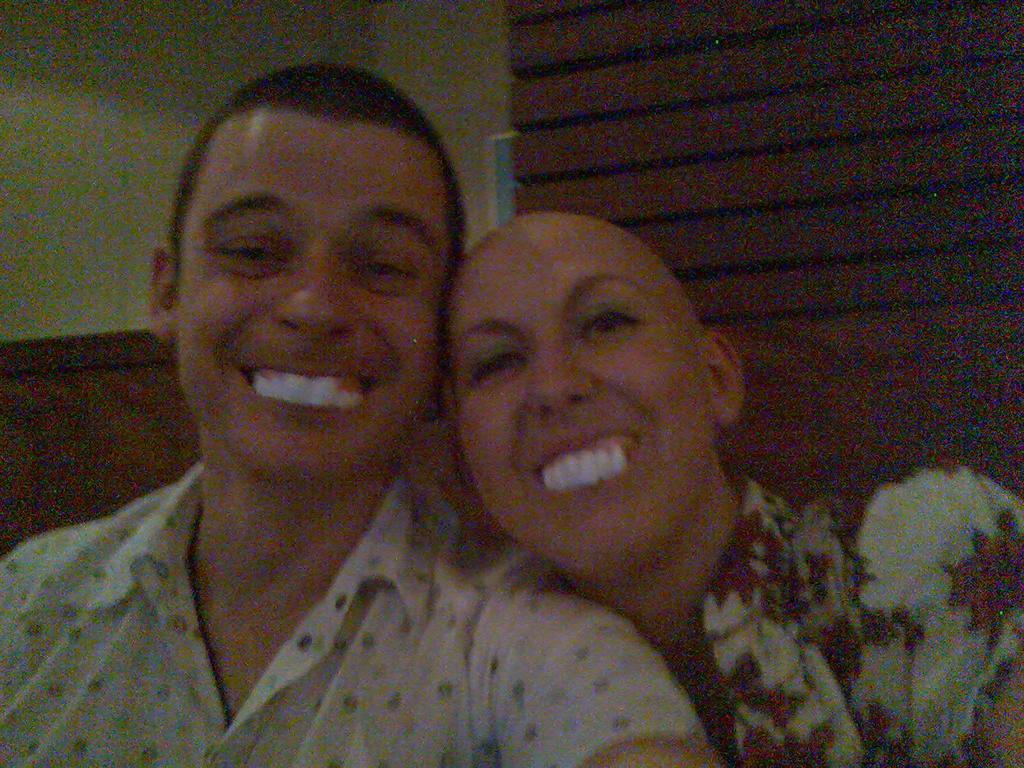Describe this image in one or two sentences. In this image there is a man and a lady. They both are smiling. In the background there is a wall. The lady is wearing a floral print shirt. The man is wearing a white shirt. 